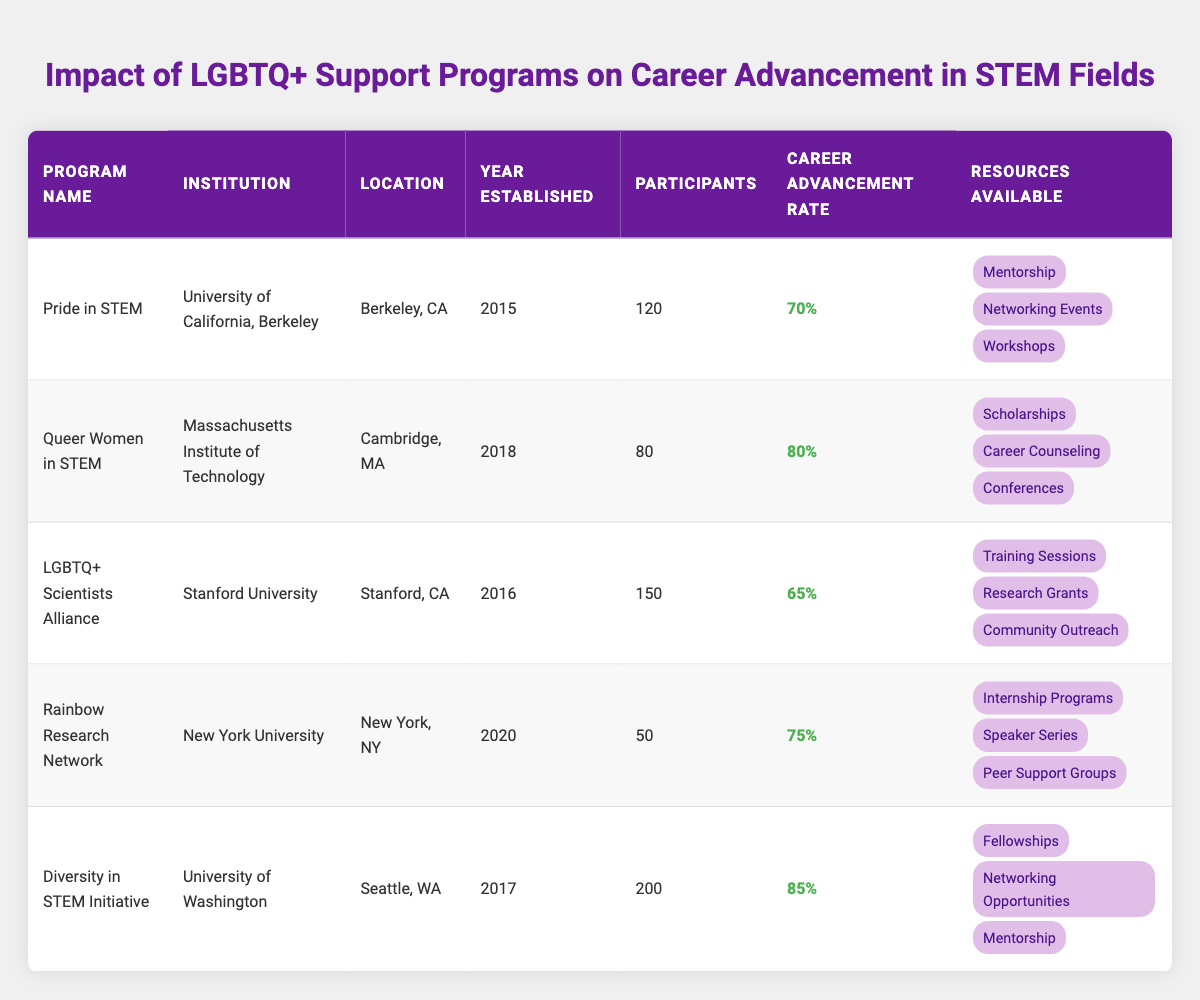What is the career advancement rate for the Diversity in STEM Initiative? The information for the Diversity in STEM Initiative is found in the table under the "Career Advancement Rate" column. It states that the rate is 85%.
Answer: 85% Which program has the highest number of participants? In the table, the "Participants" column shows that the Diversity in STEM Initiative has the highest number of participants at 200.
Answer: 200 Is there a program located in New York? Based on the table, there is a program listed under the location "New York, NY," which is the Rainbow Research Network.
Answer: Yes How many resources are available for the Queer Women in STEM program? The Queer Women in STEM program has three resources listed: Scholarships, Career Counseling, and Conferences.
Answer: 3 What is the average career advancement rate of all listed programs? To find the average, first convert the percentages to decimals: 0.70, 0.80, 0.65, 0.75, and 0.85. Then, sum these values: 0.70 + 0.80 + 0.65 + 0.75 + 0.85 = 3.75. Finally, divide by the number of programs: 3.75 / 5 = 0.75, which converts back to 75%.
Answer: 75% Which program has a career advancement rate lower than 75%? Referring to the table, I identify which programs have rates below 75%. They are Pride in STEM (70%) and LGBTQ+ Scientists Alliance (65%). Both have lower rates than 75%.
Answer: Pride in STEM and LGBTQ+ Scientists Alliance How many programs were established after 2017? From the table, I check the "Year Established" column. The programs established after 2017 are Queer Women in STEM (2018) and Rainbow Research Network (2020). This totals 2 programs.
Answer: 2 Does the LGBTQ+ Scientists Alliance provide mentorship resources? Looking at the resources for the LGBTQ+ Scientists Alliance, it is listed that it provides Training Sessions, Research Grants, and Community Outreach, with no mention of mentorship.
Answer: No Which program has the second-highest career advancement rate? The programs with career advancement rates are 85%, 80%, 75%, 70%, and 65%. The second-highest rate is 80% from the Queer Women in STEM program, following the 85% of the Diversity in STEM Initiative.
Answer: Queer Women in STEM 